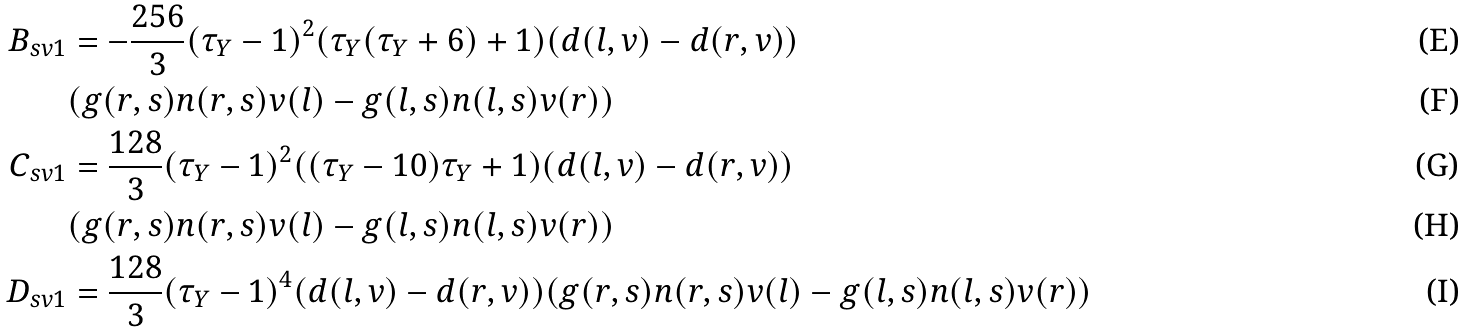<formula> <loc_0><loc_0><loc_500><loc_500>B _ { s v 1 } & = - \frac { 2 5 6 } { 3 } ( \tau _ { Y } - 1 ) ^ { 2 } ( \tau _ { Y } ( \tau _ { Y } + 6 ) + 1 ) ( d ( l , v ) - d ( r , v ) ) & & \\ & ( g ( r , s ) n ( r , s ) v ( l ) - g ( l , s ) n ( l , s ) v ( r ) ) & & \\ C _ { s v 1 } & = \frac { 1 2 8 } { 3 } ( \tau _ { Y } - 1 ) ^ { 2 } ( ( \tau _ { Y } - 1 0 ) \tau _ { Y } + 1 ) ( d ( l , v ) - d ( r , v ) ) & & \\ & ( g ( r , s ) n ( r , s ) v ( l ) - g ( l , s ) n ( l , s ) v ( r ) ) & & \\ D _ { s v 1 } & = \frac { 1 2 8 } { 3 } ( \tau _ { Y } - 1 ) ^ { 4 } ( d ( l , v ) - d ( r , v ) ) ( g ( r , s ) n ( r , s ) v ( l ) - g ( l , s ) n ( l , s ) v ( r ) ) & &</formula> 